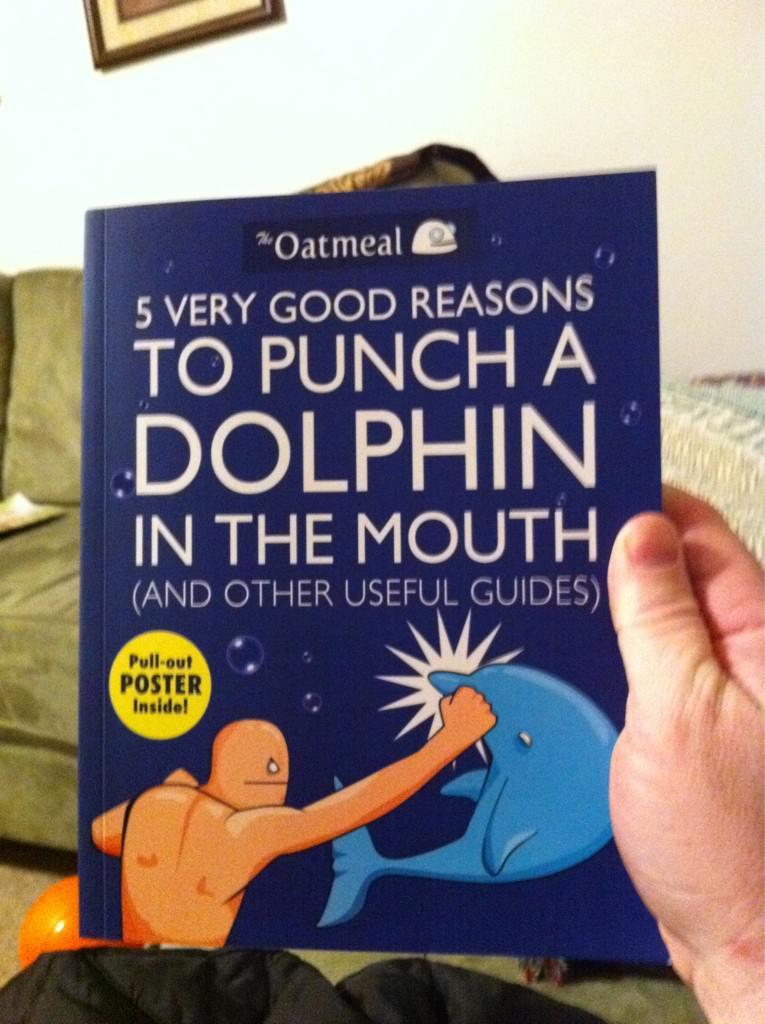What animal does the book want you to punch?
Give a very brief answer. Dolphin. What is inside the book?
Your answer should be compact. Poster. 